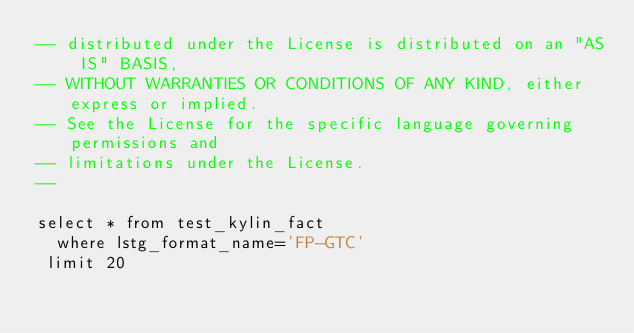Convert code to text. <code><loc_0><loc_0><loc_500><loc_500><_SQL_>-- distributed under the License is distributed on an "AS IS" BASIS,
-- WITHOUT WARRANTIES OR CONDITIONS OF ANY KIND, either express or implied.
-- See the License for the specific language governing permissions and
-- limitations under the License.
--

select * from test_kylin_fact
  where lstg_format_name='FP-GTC' 
 limit 20
</code> 